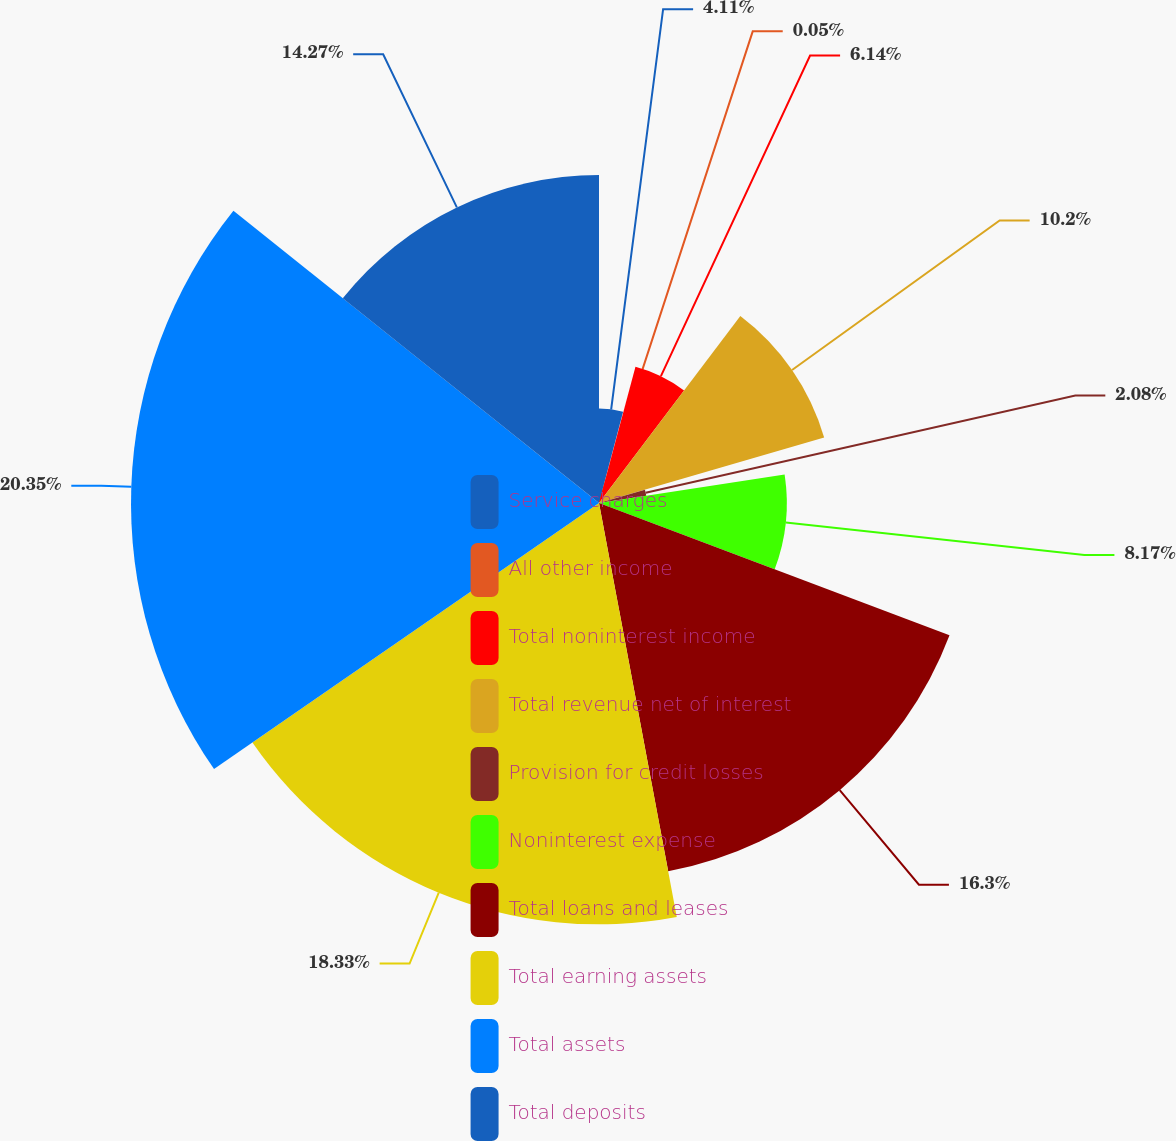Convert chart. <chart><loc_0><loc_0><loc_500><loc_500><pie_chart><fcel>Service charges<fcel>All other income<fcel>Total noninterest income<fcel>Total revenue net of interest<fcel>Provision for credit losses<fcel>Noninterest expense<fcel>Total loans and leases<fcel>Total earning assets<fcel>Total assets<fcel>Total deposits<nl><fcel>4.11%<fcel>0.05%<fcel>6.14%<fcel>10.2%<fcel>2.08%<fcel>8.17%<fcel>16.3%<fcel>18.33%<fcel>20.36%<fcel>14.27%<nl></chart> 